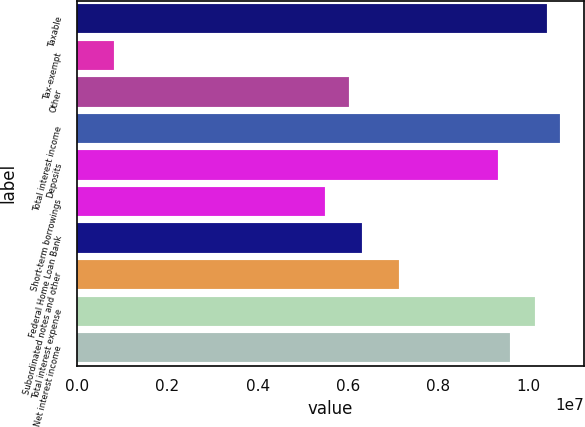<chart> <loc_0><loc_0><loc_500><loc_500><bar_chart><fcel>Taxable<fcel>Tax-exempt<fcel>Other<fcel>Total interest income<fcel>Deposits<fcel>Short-term borrowings<fcel>Federal Home Loan Bank<fcel>Subordinated notes and other<fcel>Total interest expense<fcel>Net interest income<nl><fcel>1.04233e+07<fcel>822889<fcel>6.03452e+06<fcel>1.06976e+07<fcel>9.32607e+06<fcel>5.48593e+06<fcel>6.30881e+06<fcel>7.1317e+06<fcel>1.0149e+07<fcel>9.60037e+06<nl></chart> 